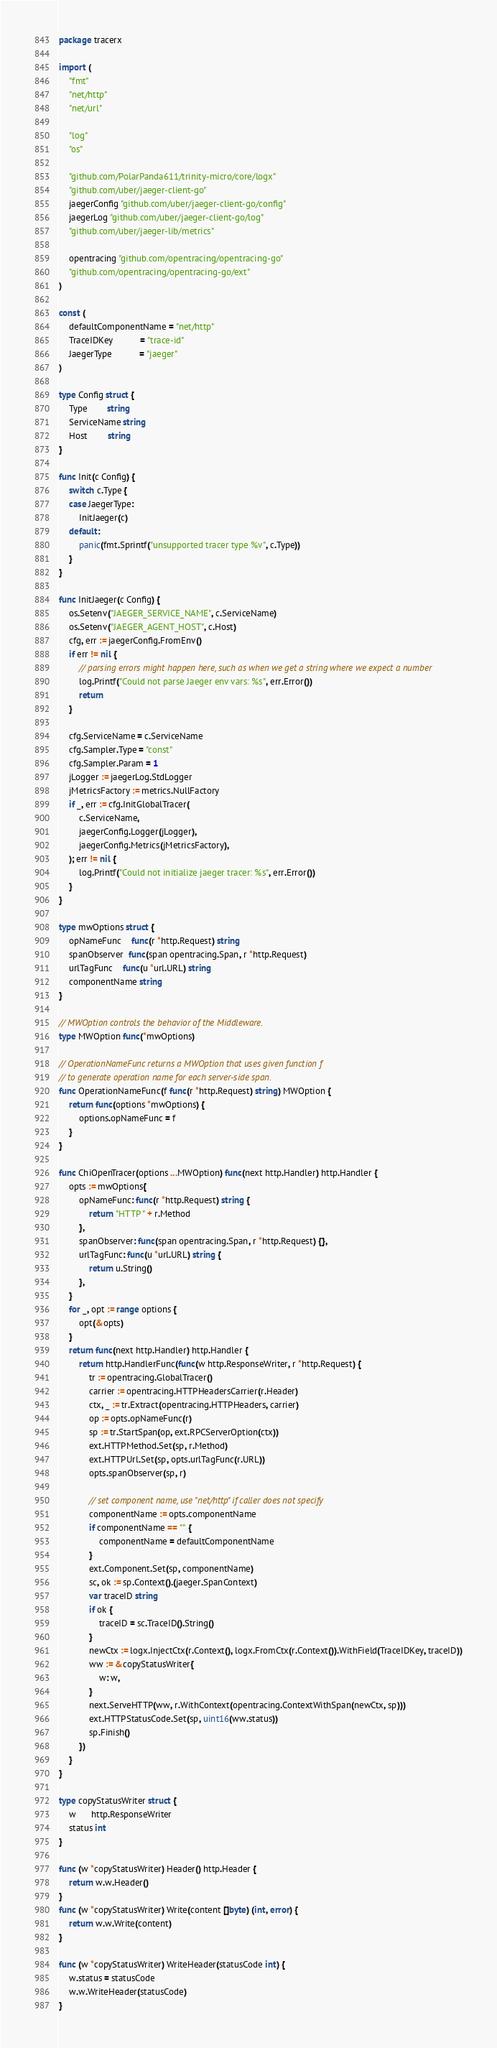<code> <loc_0><loc_0><loc_500><loc_500><_Go_>package tracerx

import (
	"fmt"
	"net/http"
	"net/url"

	"log"
	"os"

	"github.com/PolarPanda611/trinity-micro/core/logx"
	"github.com/uber/jaeger-client-go"
	jaegerConfig "github.com/uber/jaeger-client-go/config"
	jaegerLog "github.com/uber/jaeger-client-go/log"
	"github.com/uber/jaeger-lib/metrics"

	opentracing "github.com/opentracing/opentracing-go"
	"github.com/opentracing/opentracing-go/ext"
)

const (
	defaultComponentName = "net/http"
	TraceIDKey           = "trace-id"
	JaegerType           = "jaeger"
)

type Config struct {
	Type        string
	ServiceName string
	Host        string
}

func Init(c Config) {
	switch c.Type {
	case JaegerType:
		InitJaeger(c)
	default:
		panic(fmt.Sprintf("unsupported tracer type %v", c.Type))
	}
}

func InitJaeger(c Config) {
	os.Setenv("JAEGER_SERVICE_NAME", c.ServiceName)
	os.Setenv("JAEGER_AGENT_HOST", c.Host)
	cfg, err := jaegerConfig.FromEnv()
	if err != nil {
		// parsing errors might happen here, such as when we get a string where we expect a number
		log.Printf("Could not parse Jaeger env vars: %s", err.Error())
		return
	}

	cfg.ServiceName = c.ServiceName
	cfg.Sampler.Type = "const"
	cfg.Sampler.Param = 1
	jLogger := jaegerLog.StdLogger
	jMetricsFactory := metrics.NullFactory
	if _, err := cfg.InitGlobalTracer(
		c.ServiceName,
		jaegerConfig.Logger(jLogger),
		jaegerConfig.Metrics(jMetricsFactory),
	); err != nil {
		log.Printf("Could not initialize jaeger tracer: %s", err.Error())
	}
}

type mwOptions struct {
	opNameFunc    func(r *http.Request) string
	spanObserver  func(span opentracing.Span, r *http.Request)
	urlTagFunc    func(u *url.URL) string
	componentName string
}

// MWOption controls the behavior of the Middleware.
type MWOption func(*mwOptions)

// OperationNameFunc returns a MWOption that uses given function f
// to generate operation name for each server-side span.
func OperationNameFunc(f func(r *http.Request) string) MWOption {
	return func(options *mwOptions) {
		options.opNameFunc = f
	}
}

func ChiOpenTracer(options ...MWOption) func(next http.Handler) http.Handler {
	opts := mwOptions{
		opNameFunc: func(r *http.Request) string {
			return "HTTP " + r.Method
		},
		spanObserver: func(span opentracing.Span, r *http.Request) {},
		urlTagFunc: func(u *url.URL) string {
			return u.String()
		},
	}
	for _, opt := range options {
		opt(&opts)
	}
	return func(next http.Handler) http.Handler {
		return http.HandlerFunc(func(w http.ResponseWriter, r *http.Request) {
			tr := opentracing.GlobalTracer()
			carrier := opentracing.HTTPHeadersCarrier(r.Header)
			ctx, _ := tr.Extract(opentracing.HTTPHeaders, carrier)
			op := opts.opNameFunc(r)
			sp := tr.StartSpan(op, ext.RPCServerOption(ctx))
			ext.HTTPMethod.Set(sp, r.Method)
			ext.HTTPUrl.Set(sp, opts.urlTagFunc(r.URL))
			opts.spanObserver(sp, r)

			// set component name, use "net/http" if caller does not specify
			componentName := opts.componentName
			if componentName == "" {
				componentName = defaultComponentName
			}
			ext.Component.Set(sp, componentName)
			sc, ok := sp.Context().(jaeger.SpanContext)
			var traceID string
			if ok {
				traceID = sc.TraceID().String()
			}
			newCtx := logx.InjectCtx(r.Context(), logx.FromCtx(r.Context()).WithField(TraceIDKey, traceID))
			ww := &copyStatusWriter{
				w: w,
			}
			next.ServeHTTP(ww, r.WithContext(opentracing.ContextWithSpan(newCtx, sp)))
			ext.HTTPStatusCode.Set(sp, uint16(ww.status))
			sp.Finish()
		})
	}
}

type copyStatusWriter struct {
	w      http.ResponseWriter
	status int
}

func (w *copyStatusWriter) Header() http.Header {
	return w.w.Header()
}
func (w *copyStatusWriter) Write(content []byte) (int, error) {
	return w.w.Write(content)
}

func (w *copyStatusWriter) WriteHeader(statusCode int) {
	w.status = statusCode
	w.w.WriteHeader(statusCode)
}
</code> 